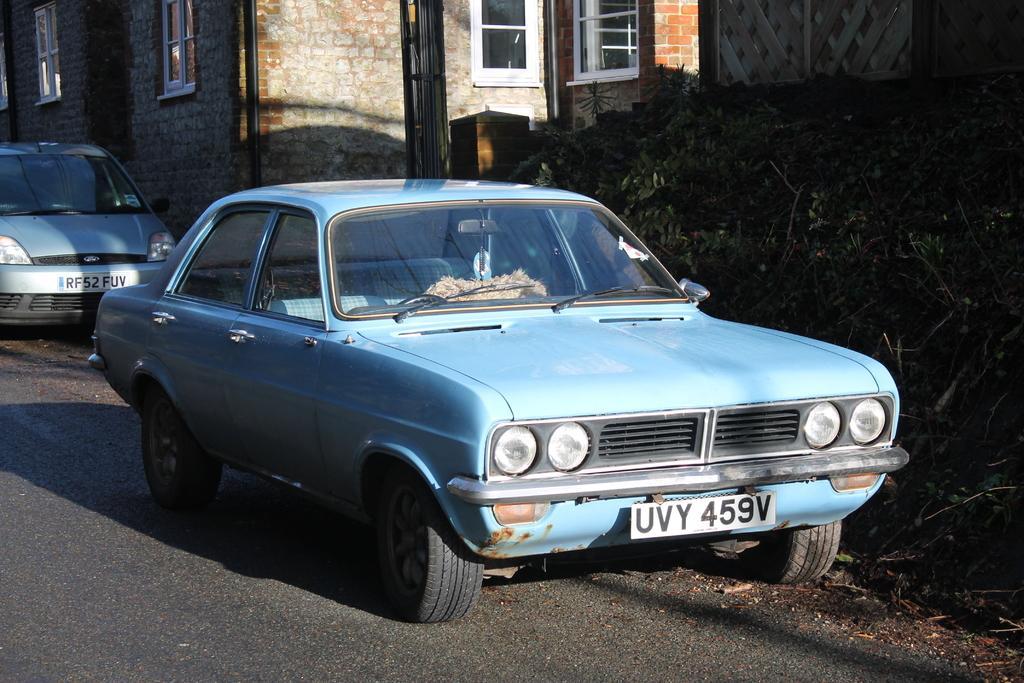In one or two sentences, can you explain what this image depicts? In the picture we can see a blue color vintage car parked near the building and beside it, we can see plant bushes and behind the car we can see another car parked near the building wall with windows and white color frames to it. 